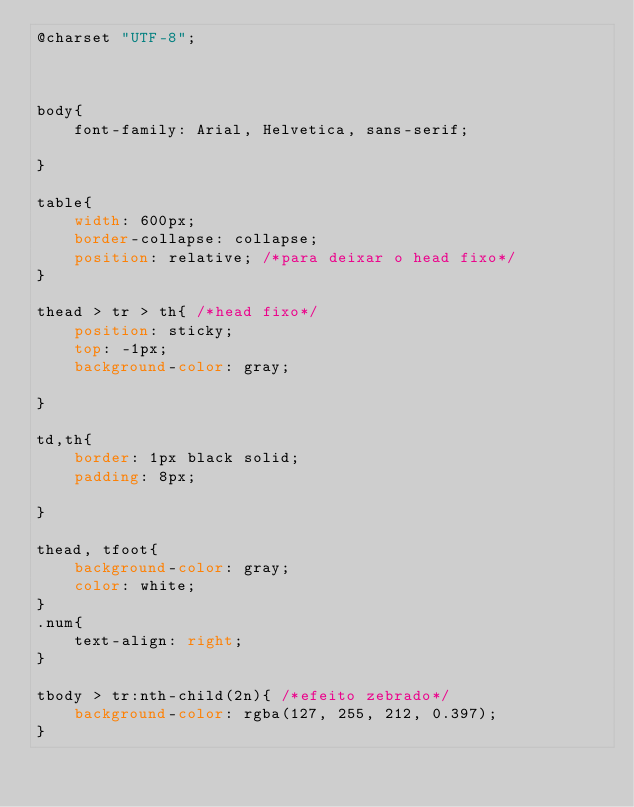Convert code to text. <code><loc_0><loc_0><loc_500><loc_500><_CSS_>@charset "UTF-8";



body{
    font-family: Arial, Helvetica, sans-serif;
    
}

table{
    width: 600px;
    border-collapse: collapse;
    position: relative; /*para deixar o head fixo*/
}

thead > tr > th{ /*head fixo*/
    position: sticky;
    top: -1px;
    background-color: gray;

}

td,th{
    border: 1px black solid;
    padding: 8px;
   
}

thead, tfoot{
    background-color: gray;
    color: white;
}
.num{
    text-align: right;
}

tbody > tr:nth-child(2n){ /*efeito zebrado*/
    background-color: rgba(127, 255, 212, 0.397);
}</code> 